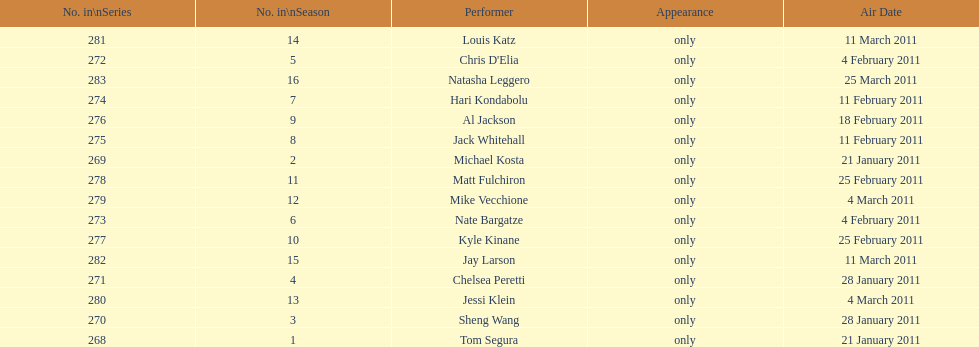How many episodes only had one performer? 16. 